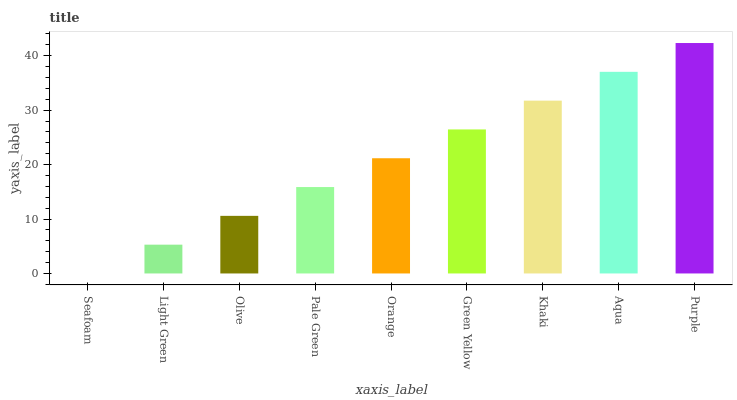Is Seafoam the minimum?
Answer yes or no. Yes. Is Purple the maximum?
Answer yes or no. Yes. Is Light Green the minimum?
Answer yes or no. No. Is Light Green the maximum?
Answer yes or no. No. Is Light Green greater than Seafoam?
Answer yes or no. Yes. Is Seafoam less than Light Green?
Answer yes or no. Yes. Is Seafoam greater than Light Green?
Answer yes or no. No. Is Light Green less than Seafoam?
Answer yes or no. No. Is Orange the high median?
Answer yes or no. Yes. Is Orange the low median?
Answer yes or no. Yes. Is Purple the high median?
Answer yes or no. No. Is Light Green the low median?
Answer yes or no. No. 